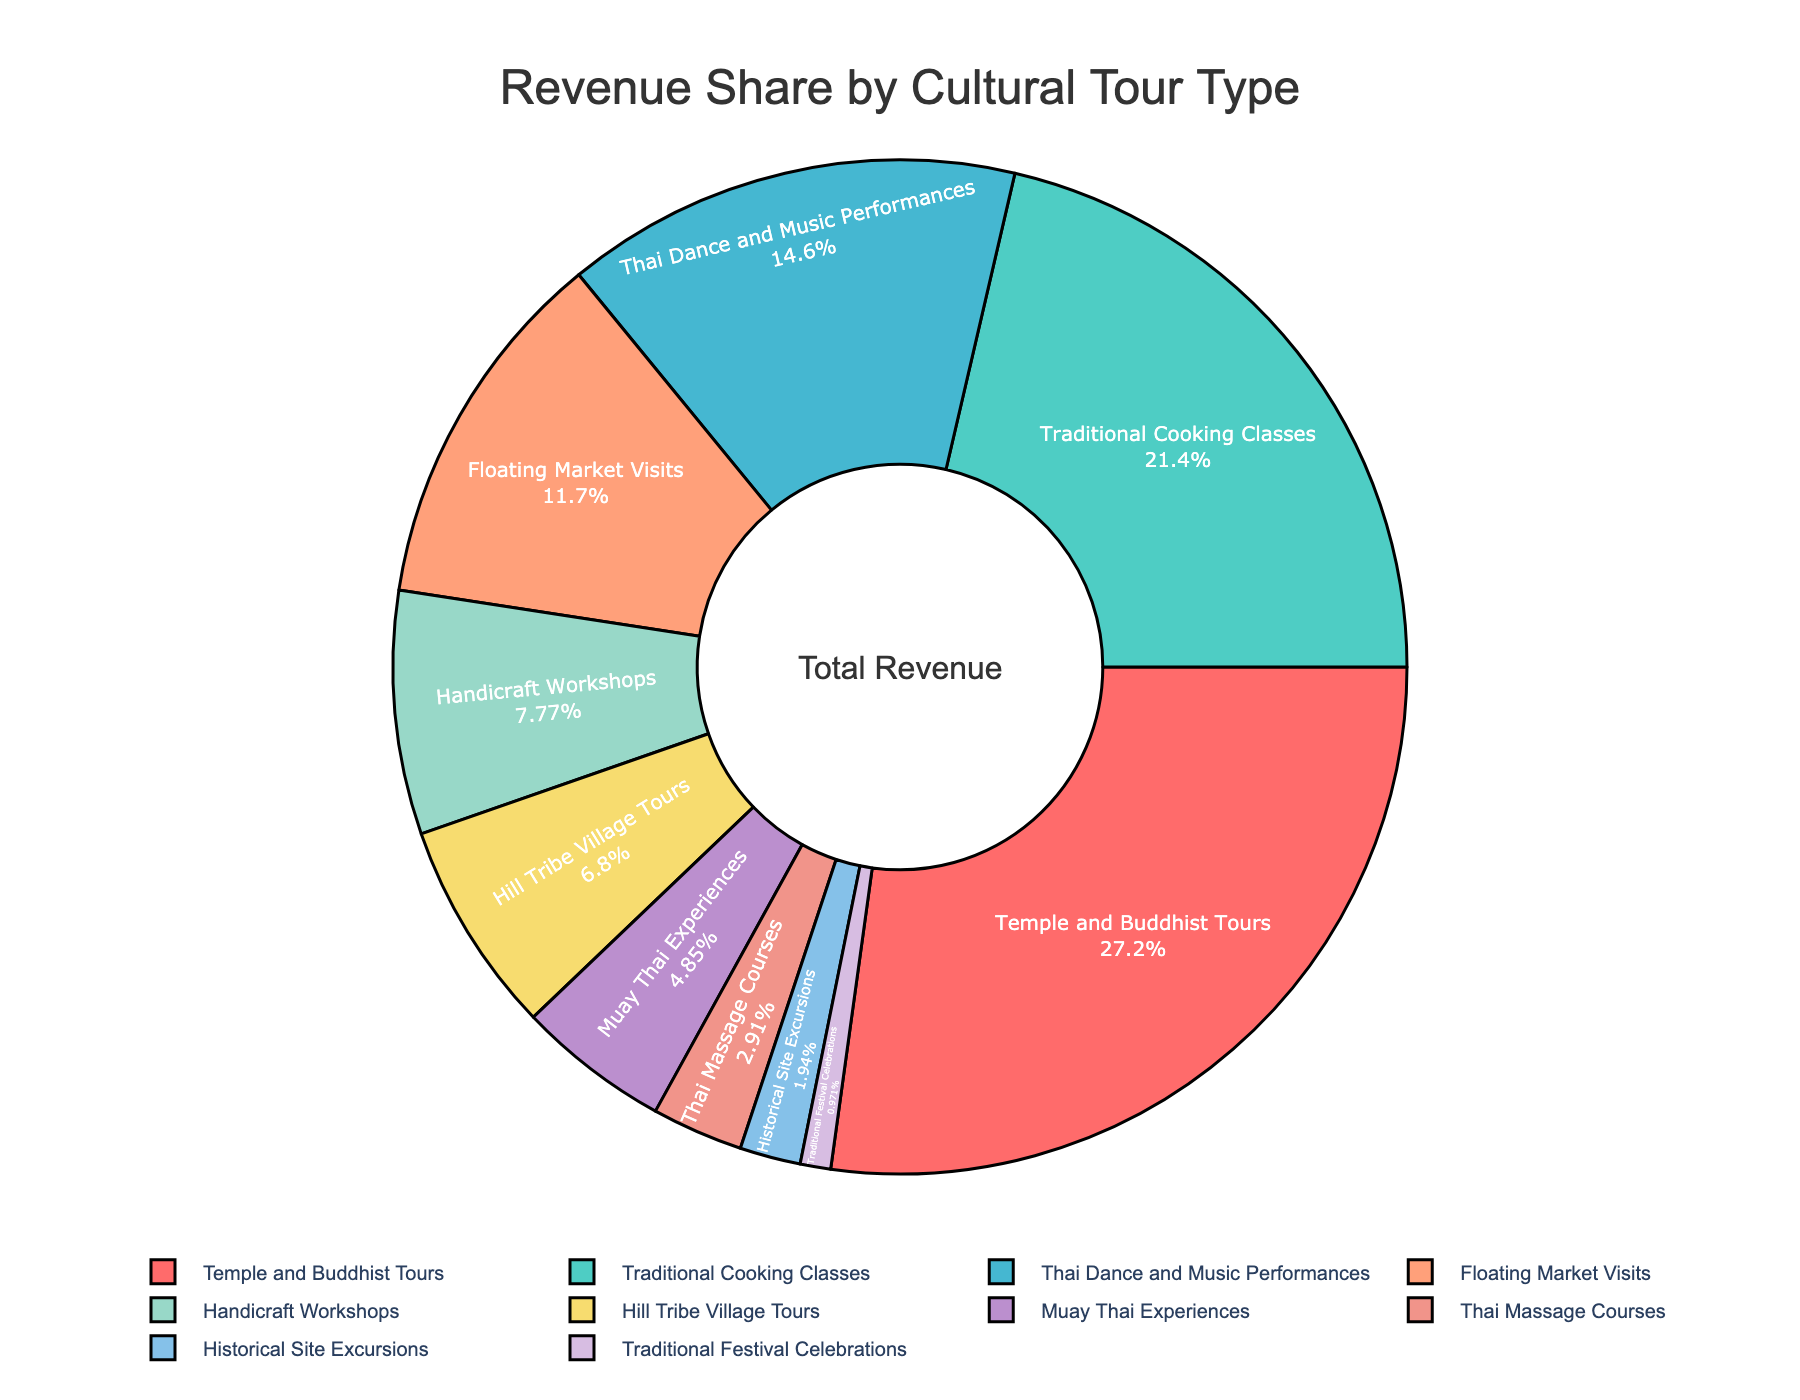Which tour type generates the most revenue? The largest segment is Temple and Buddhist Tours, which occupies 28% of the pie chart, indicating it generates the most revenue.
Answer: Temple and Buddhist Tours What is the combined revenue share of Traditional Cooking Classes and Handicraft Workshops? Traditional Cooking Classes contribute 22% and Handicraft Workshops contribute 8%; adding these gives 22% + 8% = 30%.
Answer: 30% Which tour type has a lower revenue share: Thai Dance and Music Performances or Hill Tribe Village Tours? Thai Dance and Music Performances have a 15% share, while Hill Tribe Village Tours have a 7% share, thus 7% < 15%.
Answer: Hill Tribe Village Tours What is the difference in revenue share between Floating Market Visits and Historical Site Excursions? The Floating Market Visits account for 12%, and Historical Site Excursions account for 2%. The difference is 12% - 2% = 10%.
Answer: 10% Which segment is depicted in pink, and what is its revenue share? The pink segment is Floating Market Visits, and its revenue share is 12%, as seen by the pink color on the pie chart.
Answer: Floating Market Visits, 12% What are the total contributions of all cultural tours except Temple and Buddhist Tours? The sum of revenue shares of all other tours is: 22% + 15% + 12% + 8% + 7% + 5% + 3% + 2% + 1% = 75%.
Answer: 75% How does the revenue generated by Muay Thai Experiences compare to Thai Massage Courses? Muay Thai Experiences generate 5%, while Thai Massage Courses generate 3%. Therefore, 5% is greater than 3%.
Answer: Greater What percentage of the revenue comes from tours that generate less than 10% each? Adding revenue shares for Handicraft Workshops (8%), Hill Tribe Village Tours (7%), Muay Thai Experiences (5%), Thai Massage Courses (3%), Historical Site Excursions (2%), and Traditional Festival Celebrations (1%) gives 8% + 7% + 5% + 3% + 2% + 1% = 26%.
Answer: 26% What is the revenue share of the second most popular tour type? The second-largest segment after Temple and Buddhist Tours (28%) is Traditional Cooking Classes (22%). This is the next largest segment in the pie chart.
Answer: 22% 